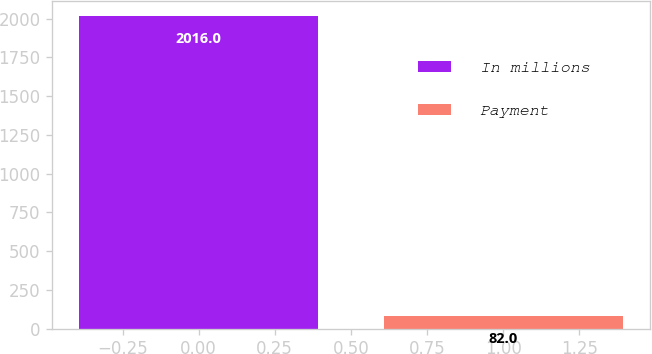Convert chart. <chart><loc_0><loc_0><loc_500><loc_500><bar_chart><fcel>In millions<fcel>Payment<nl><fcel>2016<fcel>82<nl></chart> 